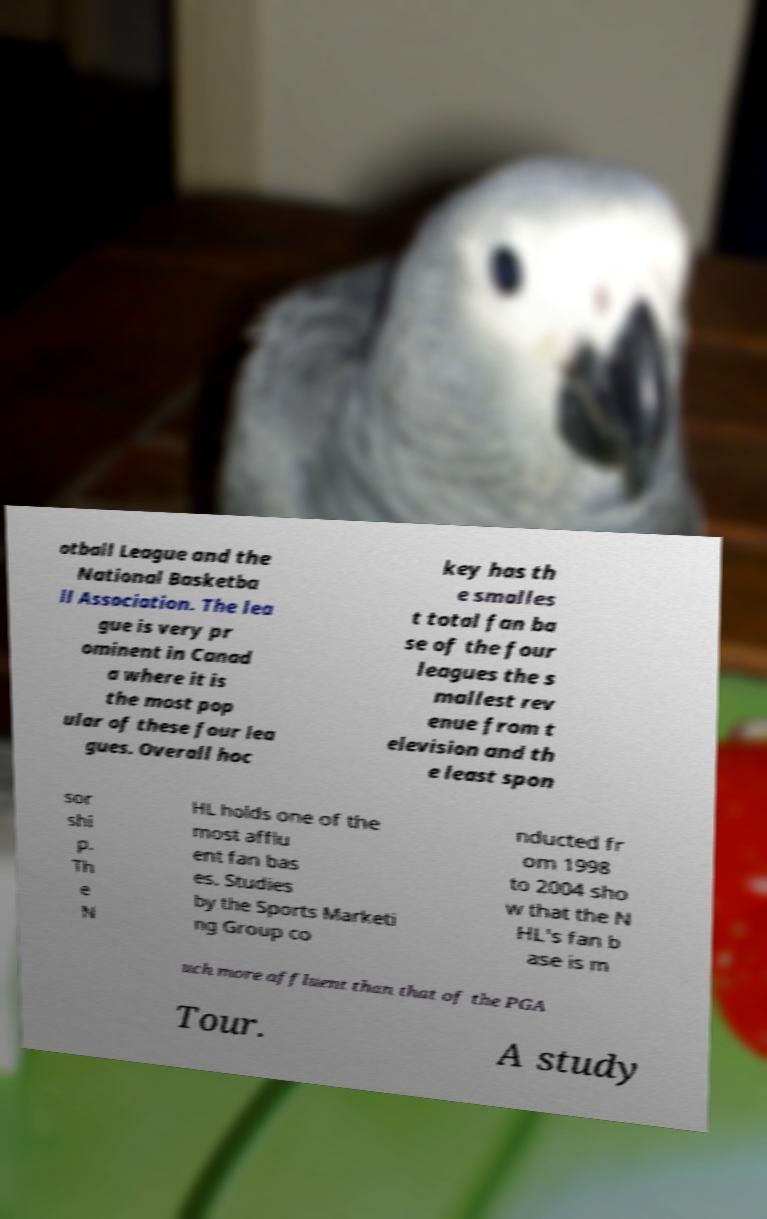What messages or text are displayed in this image? I need them in a readable, typed format. otball League and the National Basketba ll Association. The lea gue is very pr ominent in Canad a where it is the most pop ular of these four lea gues. Overall hoc key has th e smalles t total fan ba se of the four leagues the s mallest rev enue from t elevision and th e least spon sor shi p. Th e N HL holds one of the most afflu ent fan bas es. Studies by the Sports Marketi ng Group co nducted fr om 1998 to 2004 sho w that the N HL's fan b ase is m uch more affluent than that of the PGA Tour. A study 